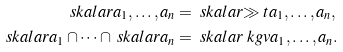<formula> <loc_0><loc_0><loc_500><loc_500>\ s k a l a r { a _ { 1 } , \dots , a _ { n } } & = \ s k a l a r { \gg t { a _ { 1 } , \dots , a _ { n } } } , \\ \ s k a l a r { a _ { 1 } } \cap \dots \cap \ s k a l a r { a _ { n } } & = \ s k a l a r { \ k g v { a _ { 1 } , \dots , a _ { n } } } .</formula> 